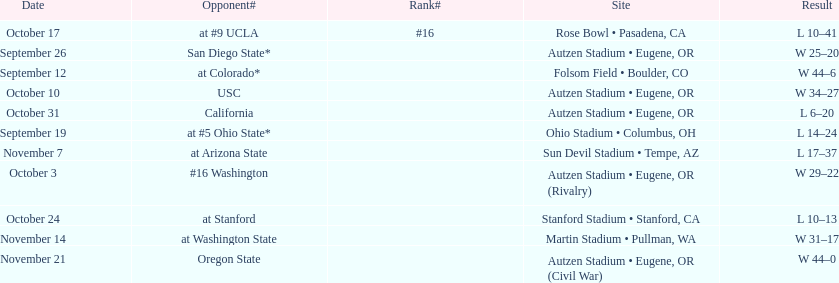Between september 26 and october 24, how many games were played in eugene, or? 3. 